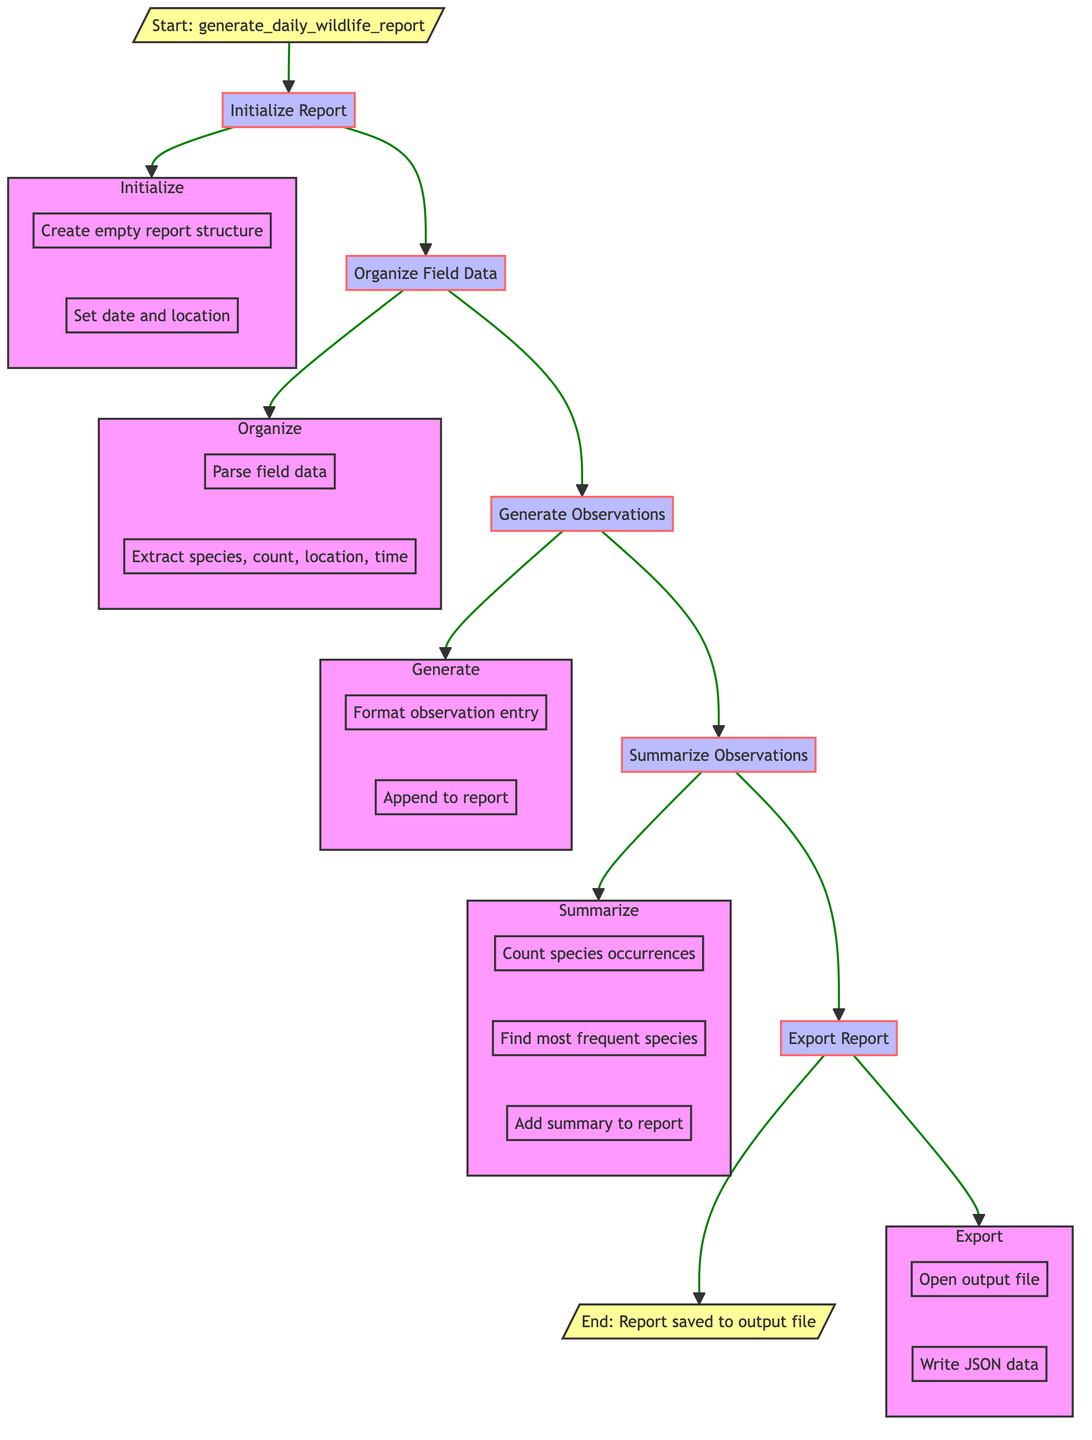What is the first step in the flowchart? The first step in the flowchart is labeled "Initialize Report," which indicates the beginning of the report generation process where an empty report structure is created.
Answer: Initialize Report How many primary steps are in the diagram? There are six primary steps in the diagram that detail the process of generating the daily wildlife report, which includes initializing the report, organizing field data, generating observations, summarizing observations, and exporting the report.
Answer: Six What does the "Summarize Observations" step include? The "Summarize Observations" step includes counting species occurrences, finding the most frequent species, and adding the summary to the report, indicating that it consolidates key information about the observations.
Answer: Counting, finding, adding Which step occurs after exporting the report? After exporting the report, the next step is the end of the process, which indicates that the report has been saved to the output file. Thus, no further actions follow this step.
Answer: End What is the purpose of the "Initialize Report" step? The purpose of the "Initialize Report" step is to create an empty report structure, including essential information such as the current date and the location in Tasmania, which sets the foundation for the entire reporting process.
Answer: Create report structure What is the final action in the flowchart? The final action in the flowchart is to write the final report to a specified output file in JSON format, which completes the report generation process.
Answer: Write to file 